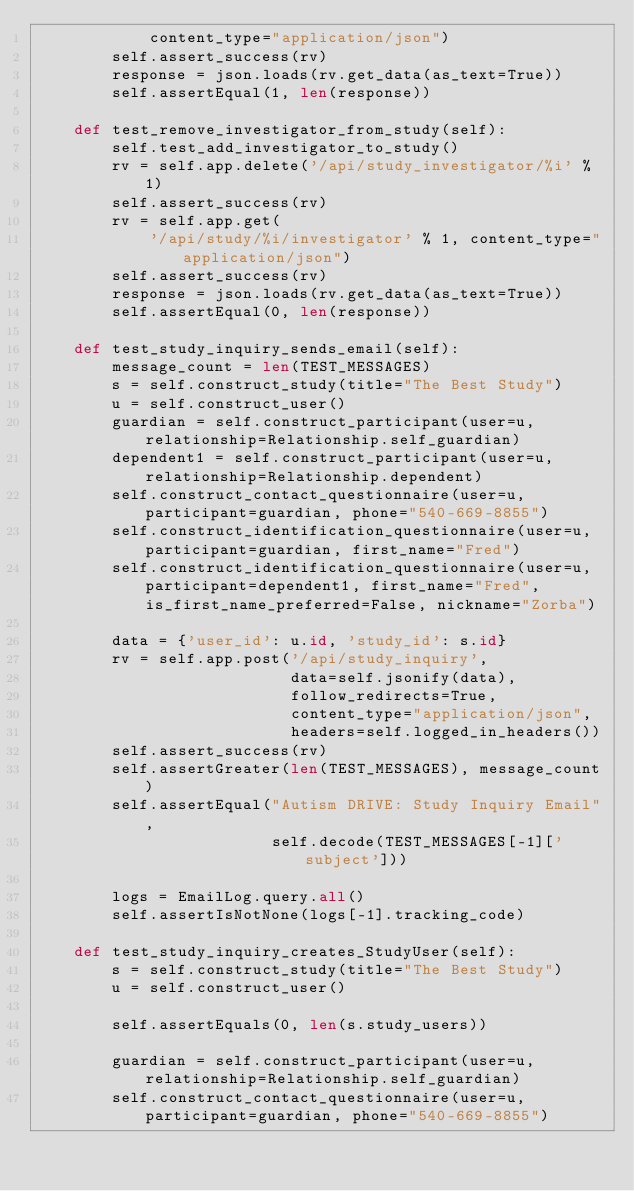Convert code to text. <code><loc_0><loc_0><loc_500><loc_500><_Python_>            content_type="application/json")
        self.assert_success(rv)
        response = json.loads(rv.get_data(as_text=True))
        self.assertEqual(1, len(response))

    def test_remove_investigator_from_study(self):
        self.test_add_investigator_to_study()
        rv = self.app.delete('/api/study_investigator/%i' % 1)
        self.assert_success(rv)
        rv = self.app.get(
            '/api/study/%i/investigator' % 1, content_type="application/json")
        self.assert_success(rv)
        response = json.loads(rv.get_data(as_text=True))
        self.assertEqual(0, len(response))

    def test_study_inquiry_sends_email(self):
        message_count = len(TEST_MESSAGES)
        s = self.construct_study(title="The Best Study")
        u = self.construct_user()
        guardian = self.construct_participant(user=u, relationship=Relationship.self_guardian)
        dependent1 = self.construct_participant(user=u, relationship=Relationship.dependent)
        self.construct_contact_questionnaire(user=u, participant=guardian, phone="540-669-8855")
        self.construct_identification_questionnaire(user=u, participant=guardian, first_name="Fred")
        self.construct_identification_questionnaire(user=u, participant=dependent1, first_name="Fred", is_first_name_preferred=False, nickname="Zorba")

        data = {'user_id': u.id, 'study_id': s.id}
        rv = self.app.post('/api/study_inquiry',
                           data=self.jsonify(data),
                           follow_redirects=True,
                           content_type="application/json",
                           headers=self.logged_in_headers())
        self.assert_success(rv)
        self.assertGreater(len(TEST_MESSAGES), message_count)
        self.assertEqual("Autism DRIVE: Study Inquiry Email",
                         self.decode(TEST_MESSAGES[-1]['subject']))

        logs = EmailLog.query.all()
        self.assertIsNotNone(logs[-1].tracking_code)

    def test_study_inquiry_creates_StudyUser(self):
        s = self.construct_study(title="The Best Study")
        u = self.construct_user()

        self.assertEquals(0, len(s.study_users))

        guardian = self.construct_participant(user=u, relationship=Relationship.self_guardian)
        self.construct_contact_questionnaire(user=u, participant=guardian, phone="540-669-8855")</code> 